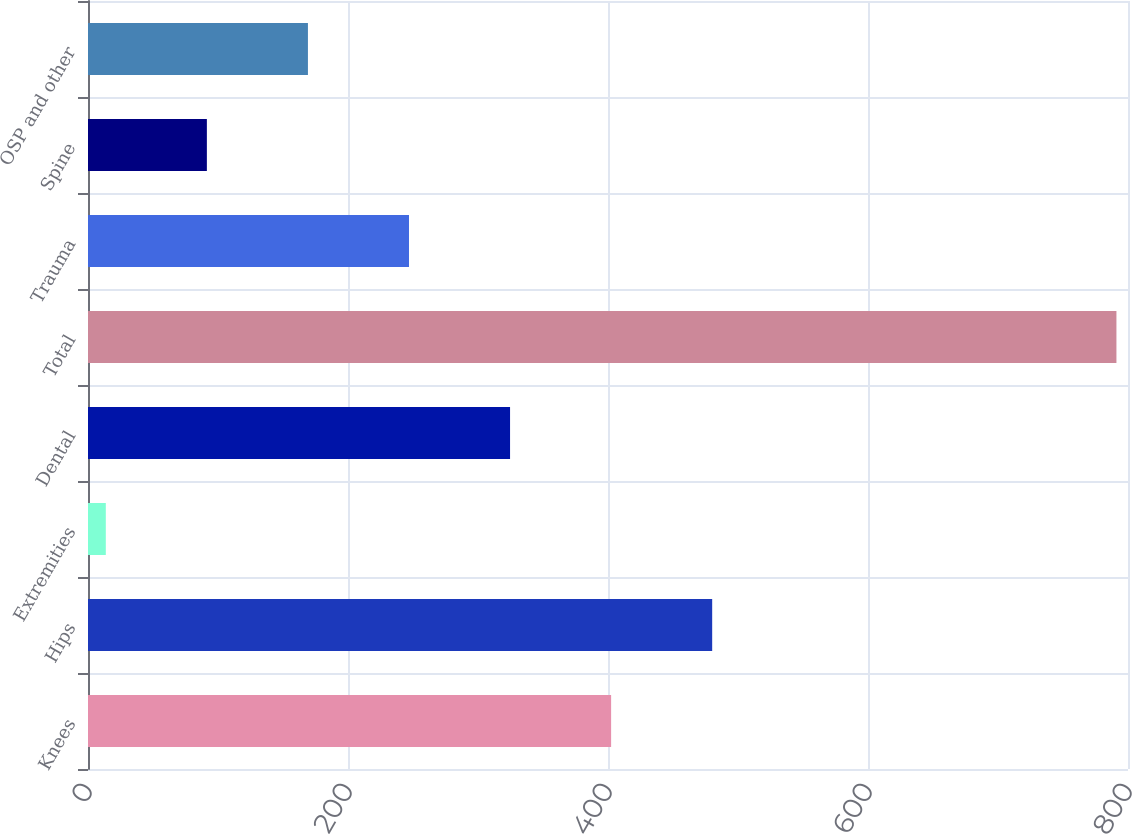<chart> <loc_0><loc_0><loc_500><loc_500><bar_chart><fcel>Knees<fcel>Hips<fcel>Extremities<fcel>Dental<fcel>Total<fcel>Trauma<fcel>Spine<fcel>OSP and other<nl><fcel>402.4<fcel>480.14<fcel>13.7<fcel>324.66<fcel>791.1<fcel>246.92<fcel>91.44<fcel>169.18<nl></chart> 